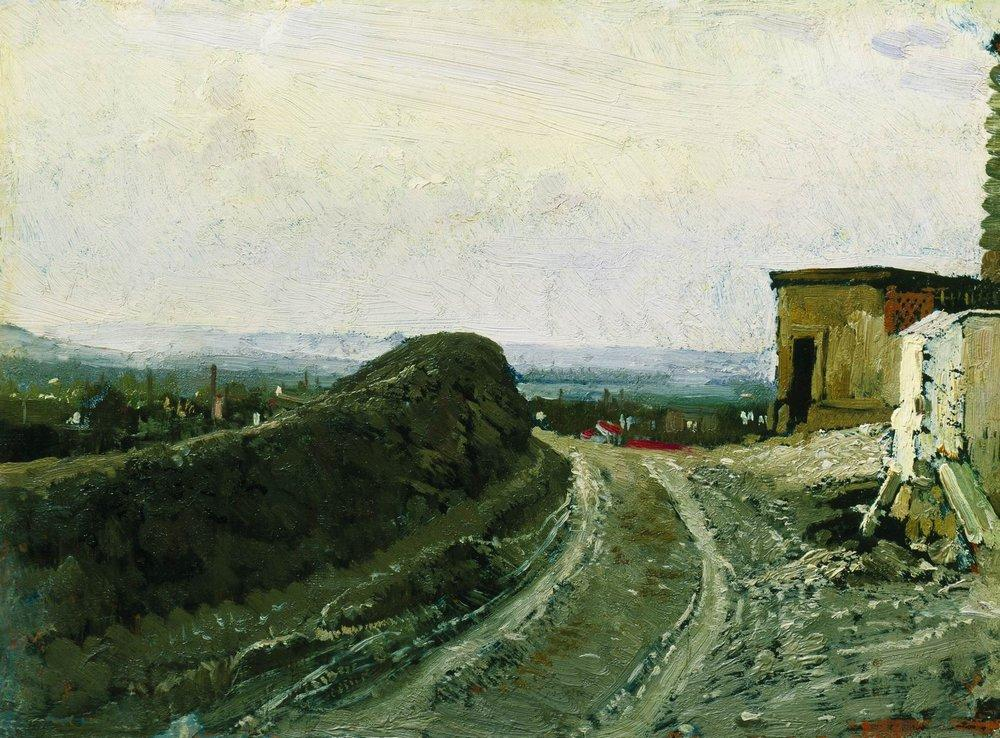Consider the mood conveyed by the painting. How does the artist achieve this atmosphere? The artist achieves a peaceful, tranquil mood through the use of a soft, harmonious color palette and gentle, fluid brushstrokes that blend the elements together seamlessly. The winding path, leading the eye through the landscape, adds a sense of depth and exploration, inviting viewers to wander through the scene. The subtle inclusion of the distant town under a hazy sky evokes a feeling of vast, open space, reinforcing the tranquility and solitude of the rural setting. 